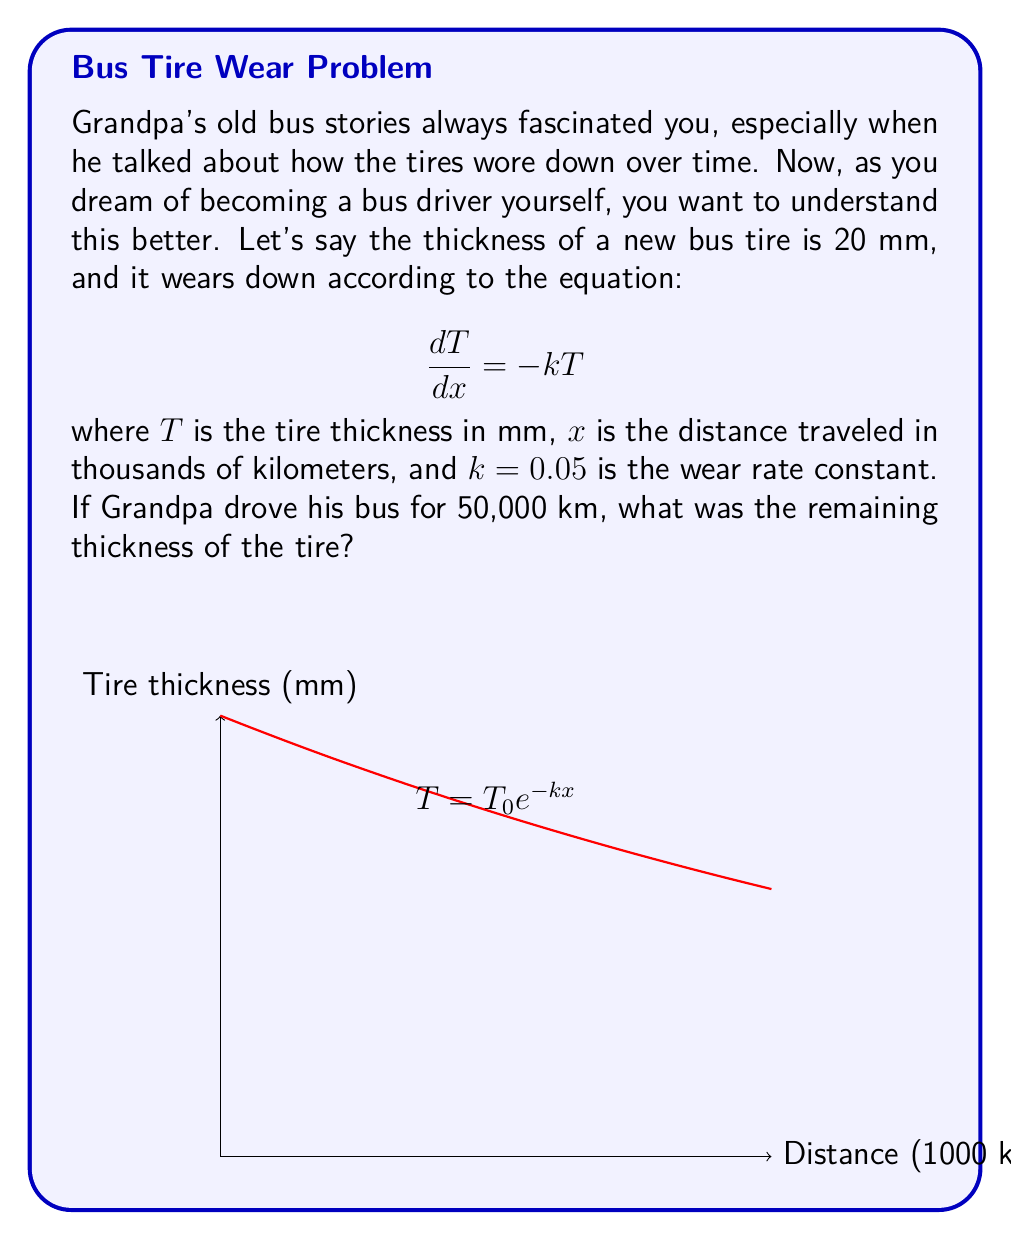Show me your answer to this math problem. To solve this problem, we'll follow these steps:

1) The differential equation $\frac{dT}{dx} = -kT$ is a first-order separable equation. Its solution is:

   $$T = T_0e^{-kx}$$

   where $T_0$ is the initial thickness.

2) We're given:
   - Initial thickness $T_0 = 20$ mm
   - Wear rate constant $k = 0.05$
   - Distance traveled $x = 50$ (in thousands of km)

3) Let's substitute these values into our equation:

   $$T = 20e^{-0.05(50)}$$

4) Now we can calculate:

   $$T = 20e^{-2.5}$$
   
   $$T = 20 \cdot 0.0821$$
   
   $$T = 1.642$$ mm

5) Rounding to one decimal place for practical purposes:

   $$T \approx 1.6$$ mm
Answer: 1.6 mm 